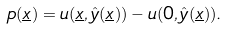Convert formula to latex. <formula><loc_0><loc_0><loc_500><loc_500>p ( \underline { x } ) = u ( \underline { x } , \hat { y } ( \underline { x } ) ) - u ( 0 , \hat { y } ( \underline { x } ) ) .</formula> 